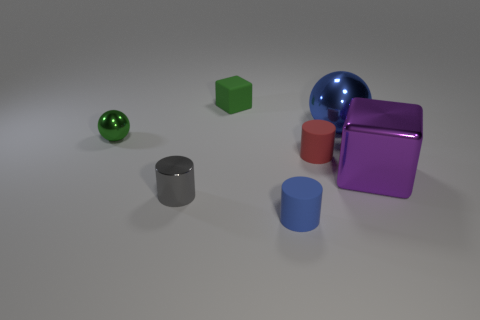There is a blue thing that is in front of the big purple shiny object; does it have the same shape as the small red thing?
Keep it short and to the point. Yes. What shape is the green object that is on the left side of the gray shiny object that is left of the cylinder that is behind the large purple metal block?
Offer a very short reply. Sphere. What size is the blue matte cylinder?
Offer a very short reply. Small. What color is the cylinder that is the same material as the tiny red object?
Provide a short and direct response. Blue. How many red things have the same material as the purple object?
Offer a terse response. 0. Is the color of the shiny cylinder the same as the tiny matte cylinder behind the tiny gray shiny thing?
Your answer should be very brief. No. What is the color of the metal sphere on the left side of the rubber cylinder behind the large purple cube?
Provide a succinct answer. Green. What color is the sphere that is the same size as the blue cylinder?
Offer a very short reply. Green. Are there any large purple objects of the same shape as the tiny gray object?
Make the answer very short. No. There is a small gray thing; what shape is it?
Ensure brevity in your answer.  Cylinder. 